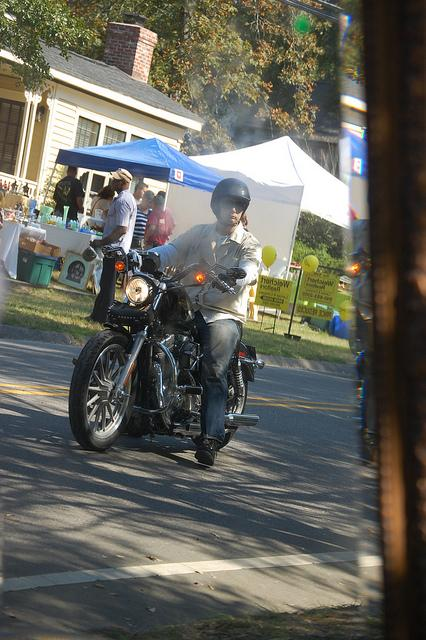What real estate structure is this type of sale often named after? Please explain your reasoning. garage. There is a garage sale being held. 